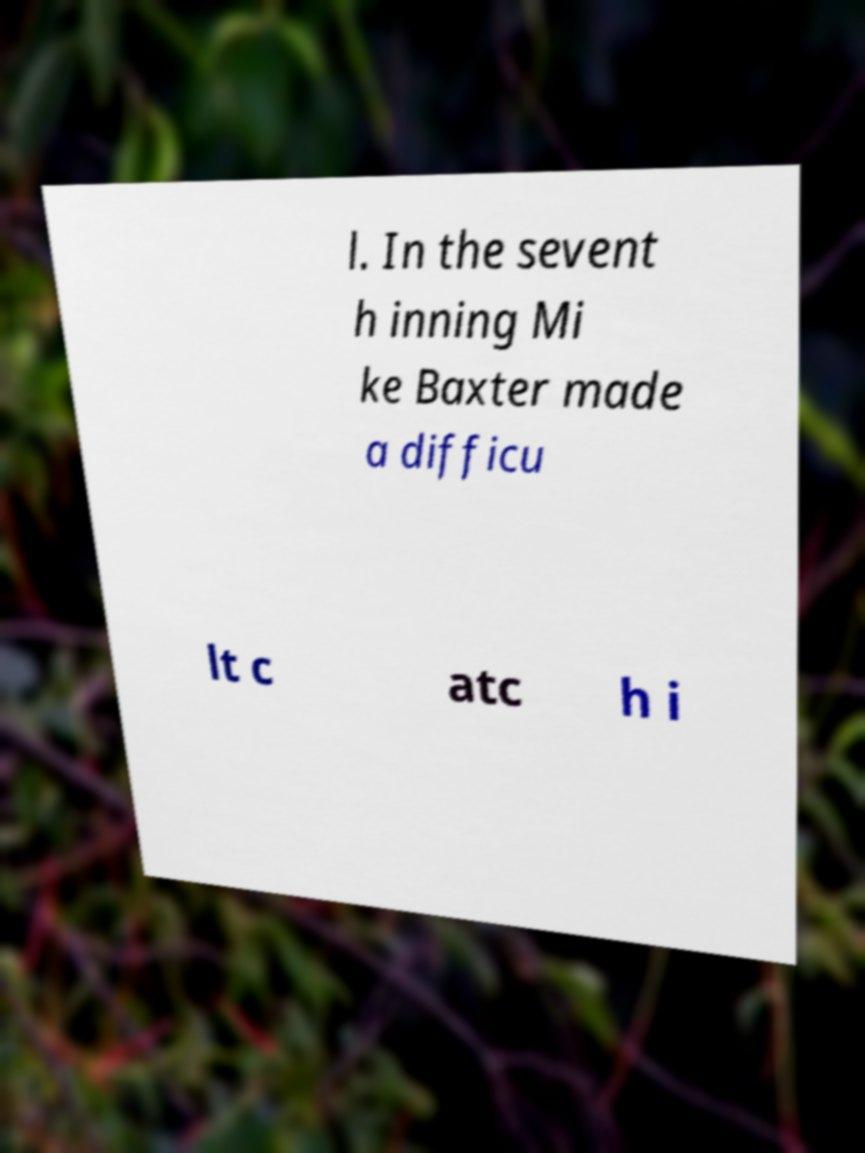Could you assist in decoding the text presented in this image and type it out clearly? l. In the sevent h inning Mi ke Baxter made a difficu lt c atc h i 